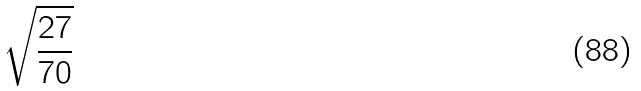Convert formula to latex. <formula><loc_0><loc_0><loc_500><loc_500>\sqrt { \frac { 2 7 } { 7 0 } }</formula> 